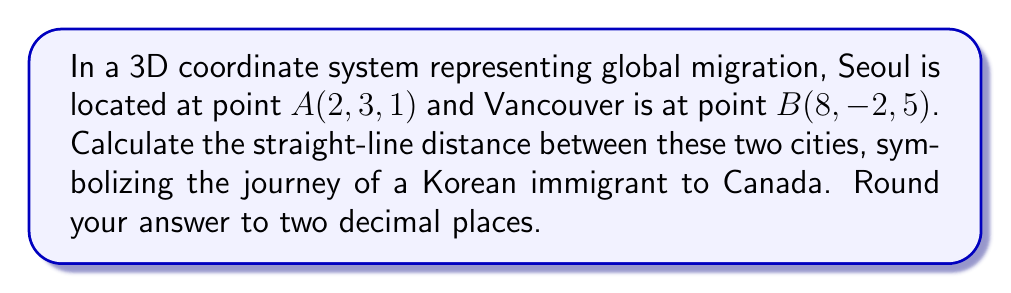Give your solution to this math problem. To find the distance between two points in 3D space, we use the distance formula derived from the Pythagorean theorem:

$$d = \sqrt{(x_2-x_1)^2 + (y_2-y_1)^2 + (z_2-z_1)^2}$$

Where $(x_1, y_1, z_1)$ are the coordinates of the first point and $(x_2, y_2, z_2)$ are the coordinates of the second point.

Let's substitute the given coordinates:
$A(x_1, y_1, z_1) = (2, 3, 1)$
$B(x_2, y_2, z_2) = (8, -2, 5)$

Now, let's calculate each term inside the square root:

$(x_2-x_1)^2 = (8-2)^2 = 6^2 = 36$
$(y_2-y_1)^2 = (-2-3)^2 = (-5)^2 = 25$
$(z_2-z_1)^2 = (5-1)^2 = 4^2 = 16$

Adding these terms:

$$d = \sqrt{36 + 25 + 16}$$
$$d = \sqrt{77}$$

Using a calculator and rounding to two decimal places:

$$d \approx 8.77$$
Answer: $8.77$ units 